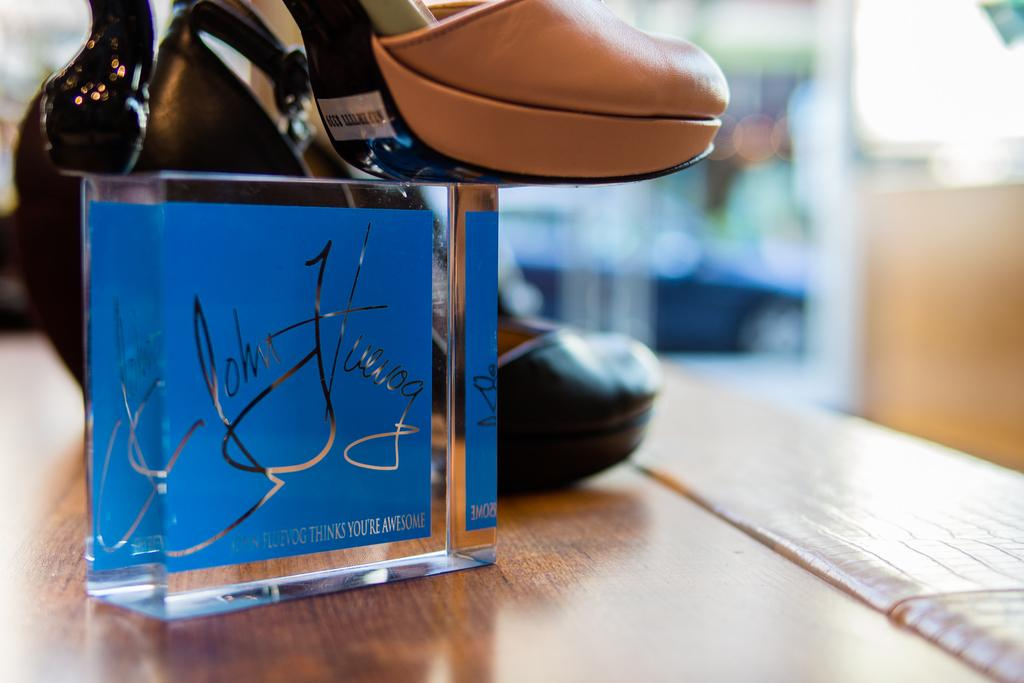What type of object is present in the image? There is footwear in the image. Where is the footwear placed? The footwear is placed on a glass item. What is the glass item resting on? The glass item is kept on a table. Which direction does the footwear face in the image? The direction the footwear faces cannot be determined from the image. Can you hear the footwear laughing in the image? There is no sound or indication of laughter in the image. 